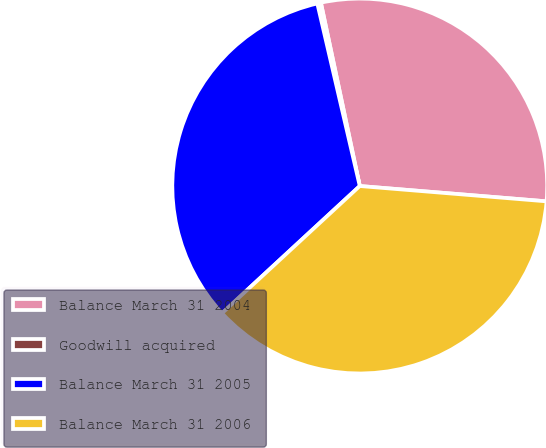Convert chart to OTSL. <chart><loc_0><loc_0><loc_500><loc_500><pie_chart><fcel>Balance March 31 2004<fcel>Goodwill acquired<fcel>Balance March 31 2005<fcel>Balance March 31 2006<nl><fcel>29.63%<fcel>0.31%<fcel>33.23%<fcel>36.83%<nl></chart> 